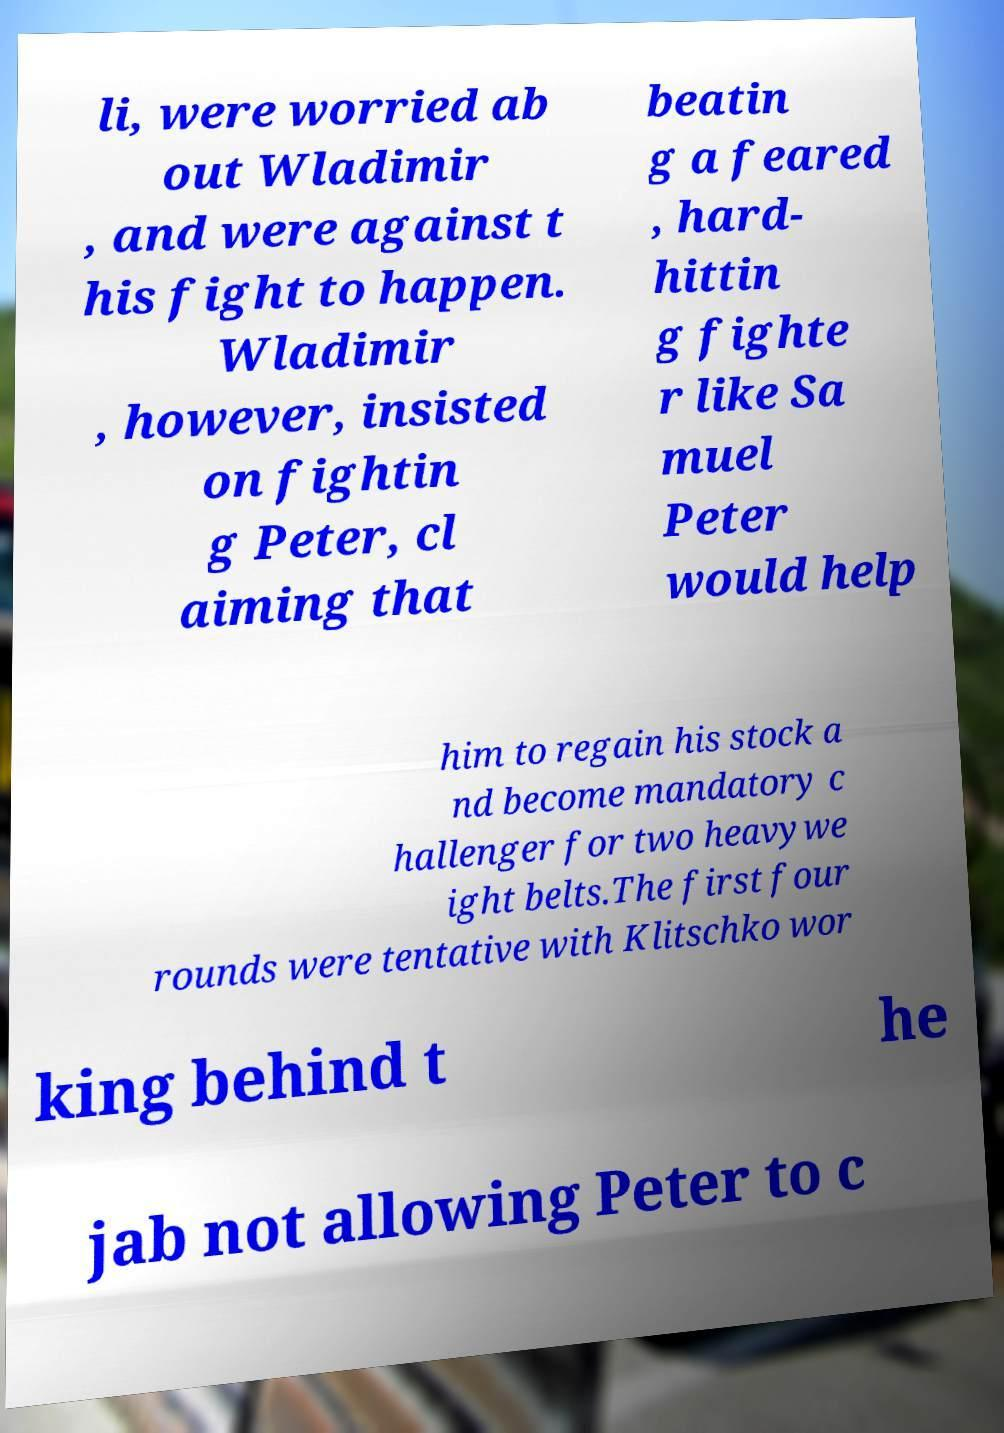What messages or text are displayed in this image? I need them in a readable, typed format. li, were worried ab out Wladimir , and were against t his fight to happen. Wladimir , however, insisted on fightin g Peter, cl aiming that beatin g a feared , hard- hittin g fighte r like Sa muel Peter would help him to regain his stock a nd become mandatory c hallenger for two heavywe ight belts.The first four rounds were tentative with Klitschko wor king behind t he jab not allowing Peter to c 